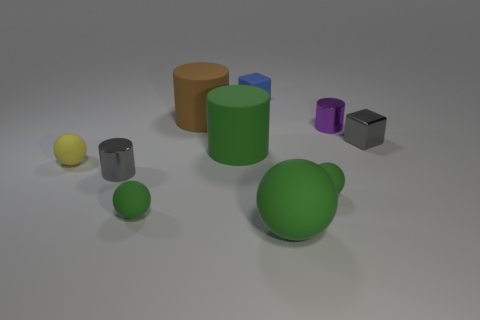The tiny gray shiny object that is on the right side of the small purple cylinder has what shape?
Make the answer very short. Cube. What is the color of the block that is the same material as the green cylinder?
Give a very brief answer. Blue. What is the material of the big green thing that is the same shape as the big brown object?
Offer a terse response. Rubber. What shape is the small yellow rubber object?
Keep it short and to the point. Sphere. What material is the thing that is both behind the gray cube and right of the blue rubber object?
Offer a very short reply. Metal. The large brown object that is made of the same material as the blue cube is what shape?
Your answer should be very brief. Cylinder. There is a green cylinder that is made of the same material as the small blue cube; what is its size?
Your answer should be very brief. Large. The tiny thing that is in front of the big brown matte cylinder and behind the small metal block has what shape?
Provide a succinct answer. Cylinder. There is a matte cylinder right of the big brown cylinder left of the big green ball; what is its size?
Ensure brevity in your answer.  Large. How many other things are there of the same color as the large sphere?
Offer a terse response. 3. 